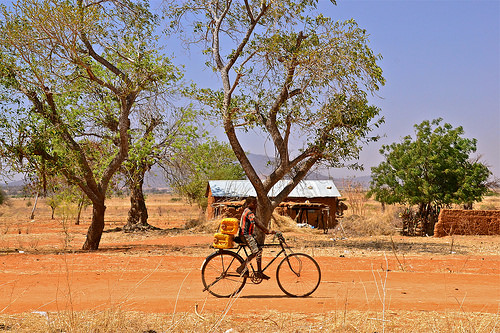<image>
Is there a bike on the tree? No. The bike is not positioned on the tree. They may be near each other, but the bike is not supported by or resting on top of the tree. 